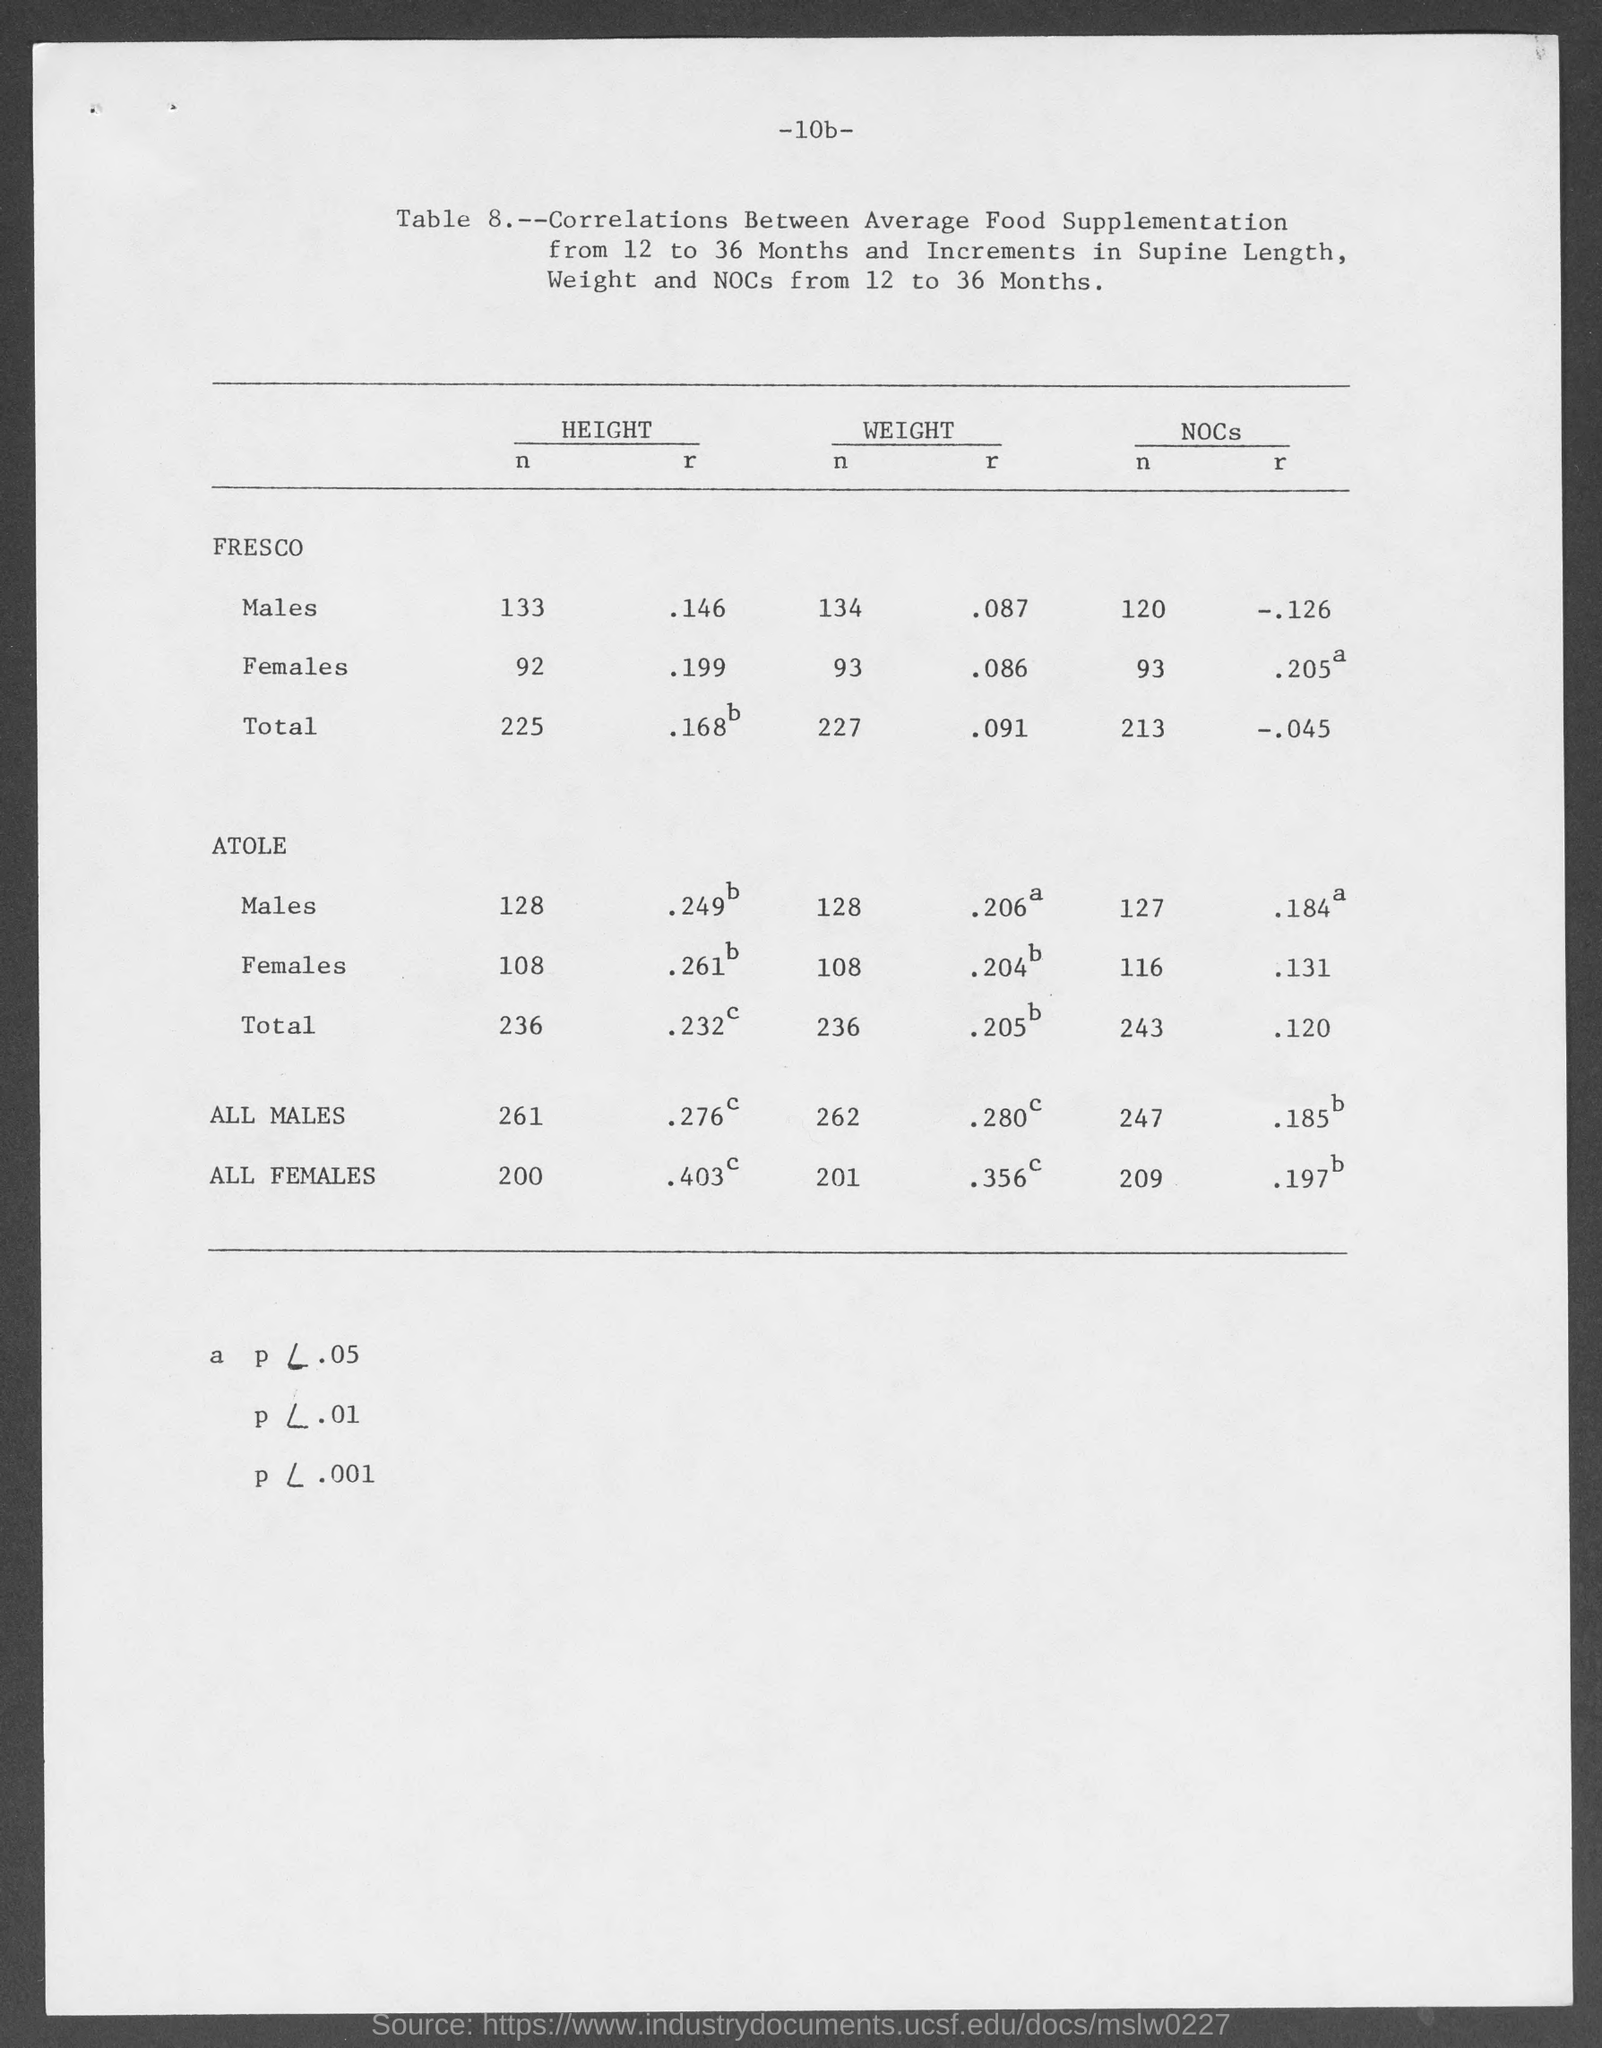Give some essential details in this illustration. According to the given page, the weight of r for males in Fresco is 0.087. What is the height of males in Fresco mentioned in the given page? It is 133... The height of females in Fresco, as mentioned in the given page, is 92. According to the given page, the weight of R for females in Fresco is 0.086. According to the given page, the height of N for females in Atole is 108. 